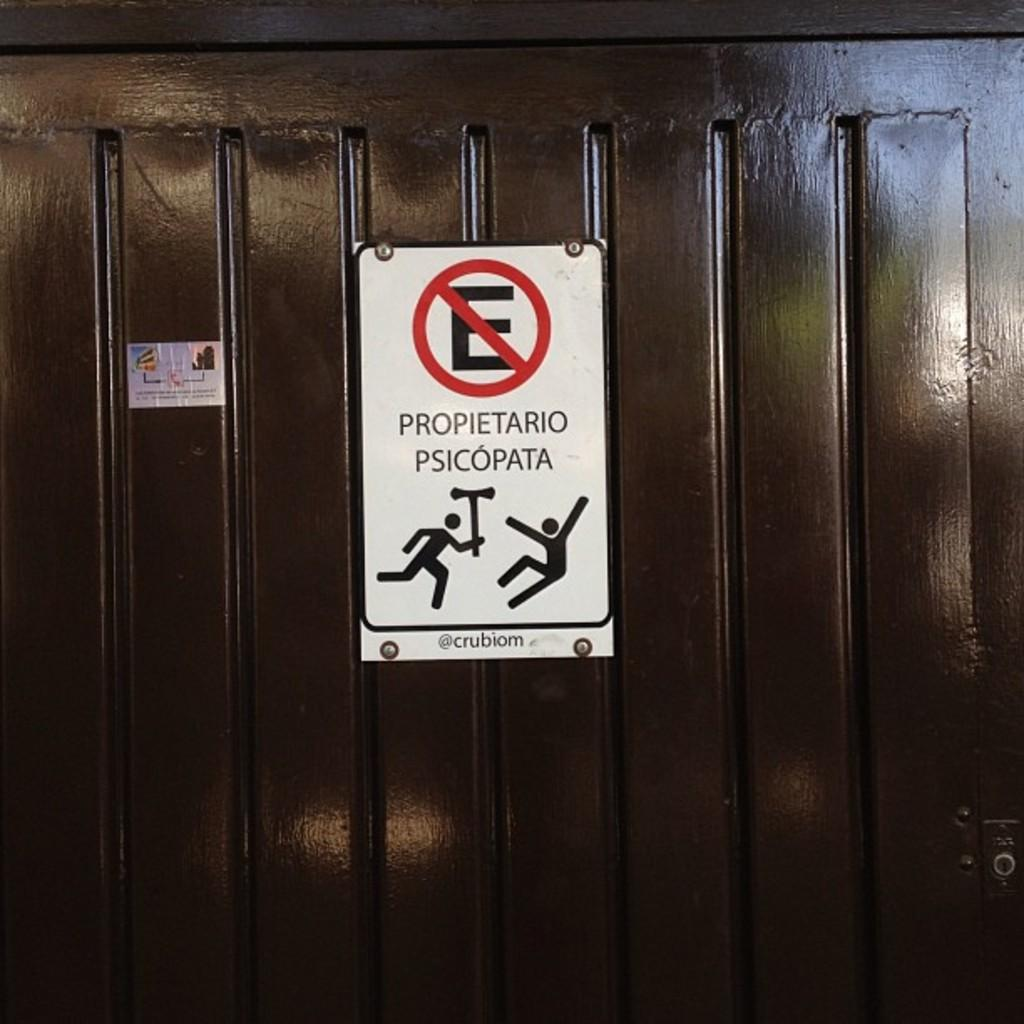What is on the board that is visible in the image? There is text on the board in the image. What type of furniture can be seen in the image? There is a cupboard in the image. Where is the crown located in the image? There is no crown present in the image. What type of establishment is the shop in the image? There is no shop present in the image. 